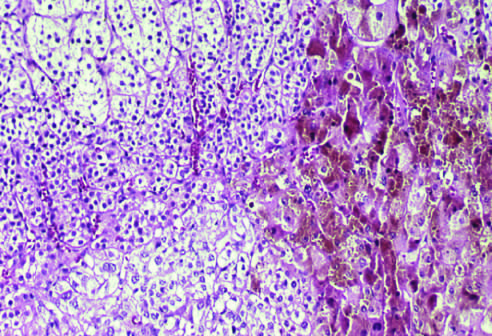re the white circles composed of cells containing lipofuscin pigment, seen in the right part of the field on histologic examination?
Answer the question using a single word or phrase. No 